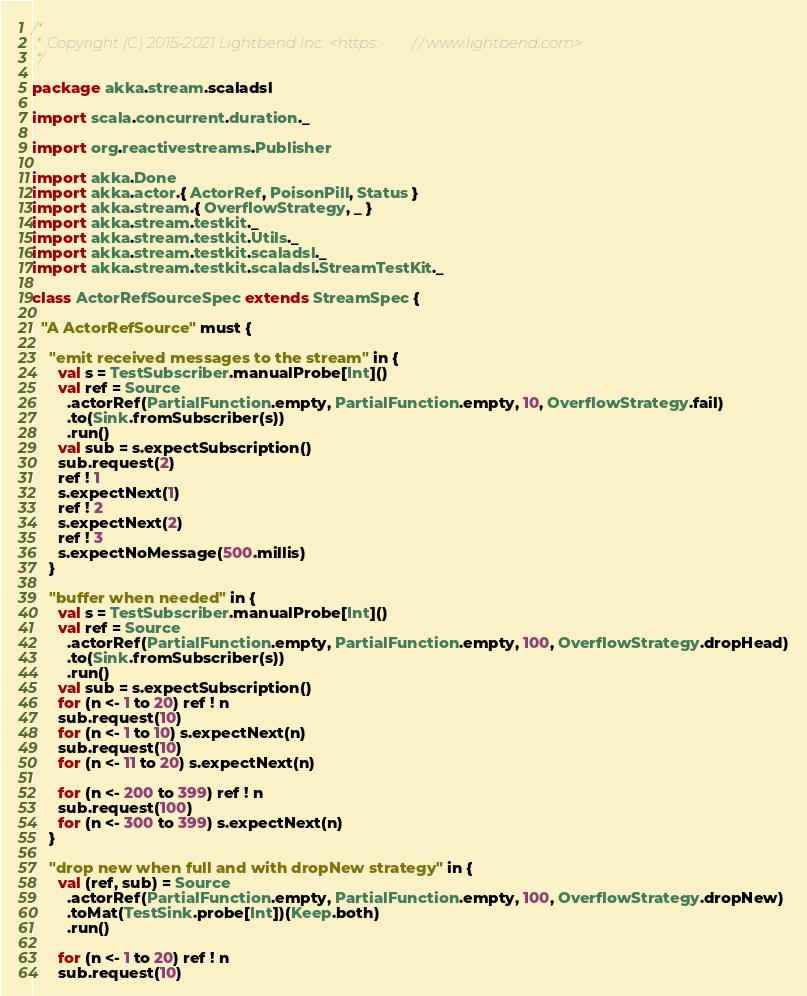Convert code to text. <code><loc_0><loc_0><loc_500><loc_500><_Scala_>/*
 * Copyright (C) 2015-2021 Lightbend Inc. <https://www.lightbend.com>
 */

package akka.stream.scaladsl

import scala.concurrent.duration._

import org.reactivestreams.Publisher

import akka.Done
import akka.actor.{ ActorRef, PoisonPill, Status }
import akka.stream.{ OverflowStrategy, _ }
import akka.stream.testkit._
import akka.stream.testkit.Utils._
import akka.stream.testkit.scaladsl._
import akka.stream.testkit.scaladsl.StreamTestKit._

class ActorRefSourceSpec extends StreamSpec {

  "A ActorRefSource" must {

    "emit received messages to the stream" in {
      val s = TestSubscriber.manualProbe[Int]()
      val ref = Source
        .actorRef(PartialFunction.empty, PartialFunction.empty, 10, OverflowStrategy.fail)
        .to(Sink.fromSubscriber(s))
        .run()
      val sub = s.expectSubscription()
      sub.request(2)
      ref ! 1
      s.expectNext(1)
      ref ! 2
      s.expectNext(2)
      ref ! 3
      s.expectNoMessage(500.millis)
    }

    "buffer when needed" in {
      val s = TestSubscriber.manualProbe[Int]()
      val ref = Source
        .actorRef(PartialFunction.empty, PartialFunction.empty, 100, OverflowStrategy.dropHead)
        .to(Sink.fromSubscriber(s))
        .run()
      val sub = s.expectSubscription()
      for (n <- 1 to 20) ref ! n
      sub.request(10)
      for (n <- 1 to 10) s.expectNext(n)
      sub.request(10)
      for (n <- 11 to 20) s.expectNext(n)

      for (n <- 200 to 399) ref ! n
      sub.request(100)
      for (n <- 300 to 399) s.expectNext(n)
    }

    "drop new when full and with dropNew strategy" in {
      val (ref, sub) = Source
        .actorRef(PartialFunction.empty, PartialFunction.empty, 100, OverflowStrategy.dropNew)
        .toMat(TestSink.probe[Int])(Keep.both)
        .run()

      for (n <- 1 to 20) ref ! n
      sub.request(10)</code> 